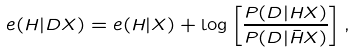<formula> <loc_0><loc_0><loc_500><loc_500>e ( H | D X ) = e ( H | X ) + \log \left [ \frac { P ( D | H X ) } { P ( D | \bar { H } X ) } \right ] ,</formula> 